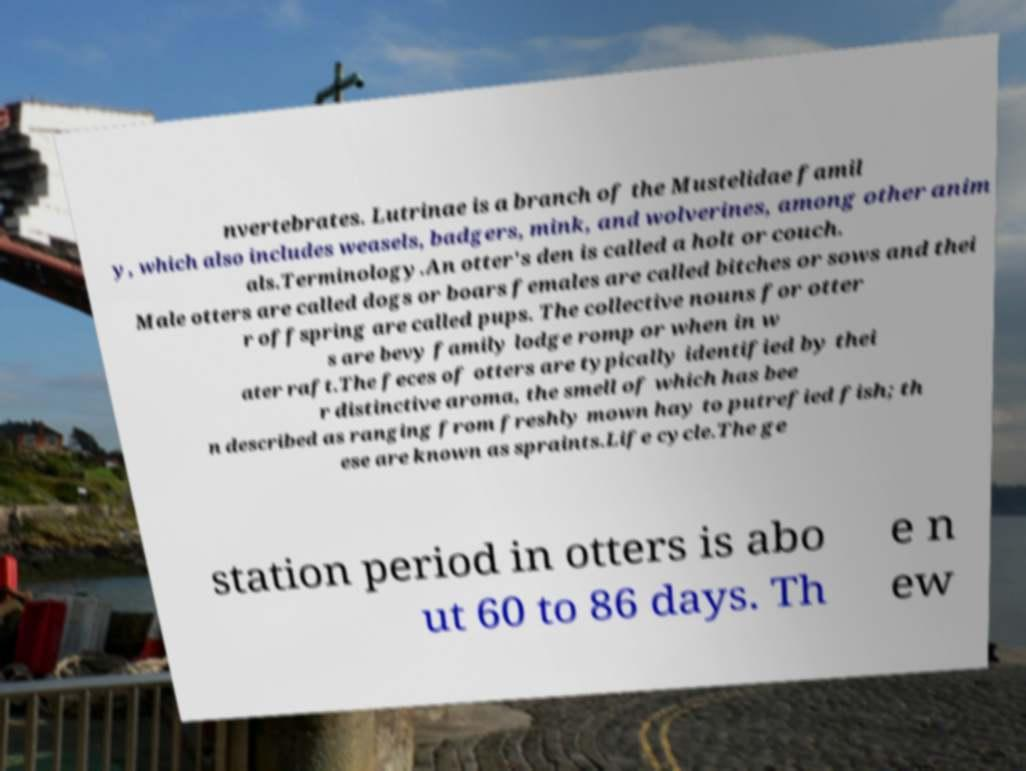What messages or text are displayed in this image? I need them in a readable, typed format. nvertebrates. Lutrinae is a branch of the Mustelidae famil y, which also includes weasels, badgers, mink, and wolverines, among other anim als.Terminology.An otter's den is called a holt or couch. Male otters are called dogs or boars females are called bitches or sows and thei r offspring are called pups. The collective nouns for otter s are bevy family lodge romp or when in w ater raft.The feces of otters are typically identified by thei r distinctive aroma, the smell of which has bee n described as ranging from freshly mown hay to putrefied fish; th ese are known as spraints.Life cycle.The ge station period in otters is abo ut 60 to 86 days. Th e n ew 